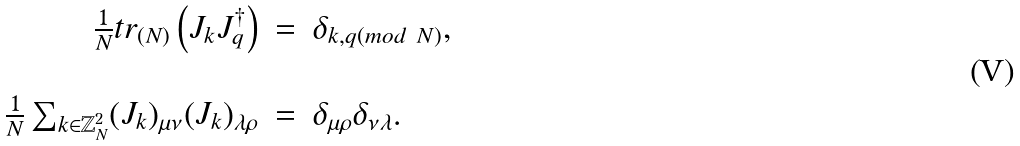Convert formula to latex. <formula><loc_0><loc_0><loc_500><loc_500>\begin{array} { r c l } \frac { 1 } { N } t r _ { ( N ) } \left ( J _ { k } J _ { q } ^ { \dag } \right ) & = & \delta _ { k , q ( m o d \ N ) } , \\ \\ \frac { 1 } { N } \sum _ { k \in \mathbb { Z } _ { N } ^ { 2 } } ( J _ { k } ) _ { \mu \nu } ( J _ { k } ) _ { \lambda \rho } & = & \delta _ { \mu \rho } \delta _ { \nu \lambda } . \end{array}</formula> 